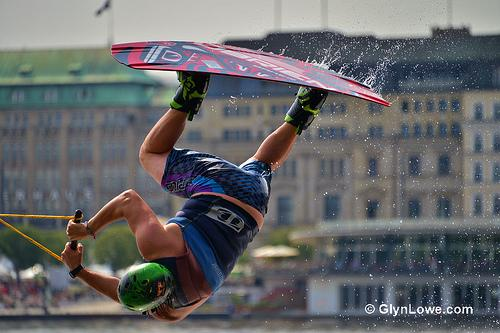What type of handle is the man holding onto, and what is it connected to? The man is holding onto a black tow rope handle that is connected to a yellow tow rope. Analyze the interaction between the man and the water board during his trick. The man is skillfully maintaining his balance on the water board while upside down, using the tow rope handle to control his orientation. Express the overall sentiment conveyed by the image. The image conveys an exciting and adventurous sentiment. In a brief sentence, explain the primary action the man is performing. The man is doing a flip on a water board while holding onto a rope handle. What type of board is the man using, and what are its predominant colors? The man is using a kite surfing board with red, blue, green, and black colors. Describe the outfit worn by the man in the image. The man is wearing a sleeveless blue shirt, blue and black checkered swim shorts, a green safety helmet, and black and purple swim trunks. What kind of trick is the man performing on the water board? He is performing a flip upside down on the water board. Count the number of buildings in the image. Two buildings are present in the image. How many different objects are attached to the water board? Three objects: boots, a flag, and the man himself. Identify the color of the helmet worn by the man in the image. Green 